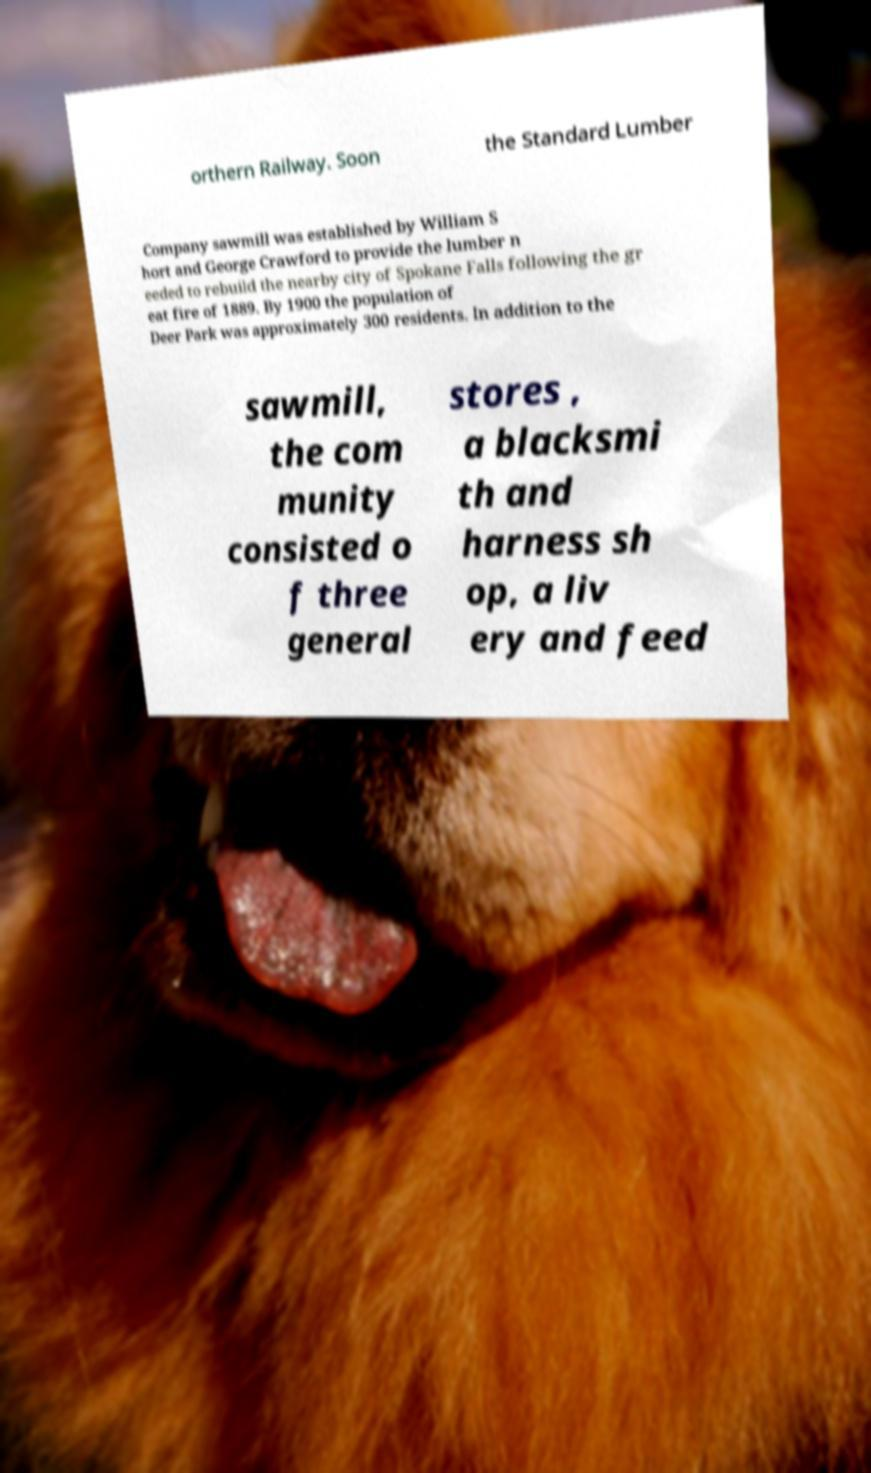Please identify and transcribe the text found in this image. orthern Railway. Soon the Standard Lumber Company sawmill was established by William S hort and George Crawford to provide the lumber n eeded to rebuild the nearby city of Spokane Falls following the gr eat fire of 1889. By 1900 the population of Deer Park was approximately 300 residents. In addition to the sawmill, the com munity consisted o f three general stores , a blacksmi th and harness sh op, a liv ery and feed 